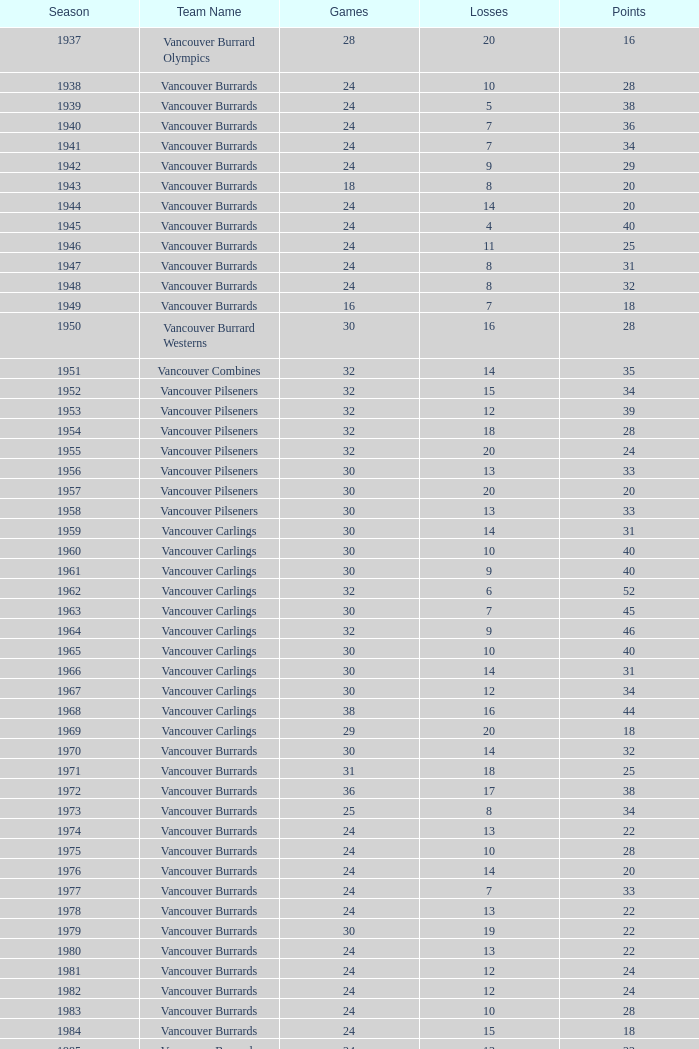What's the combined points for the 1963 season when there are more than 30 games? None. 